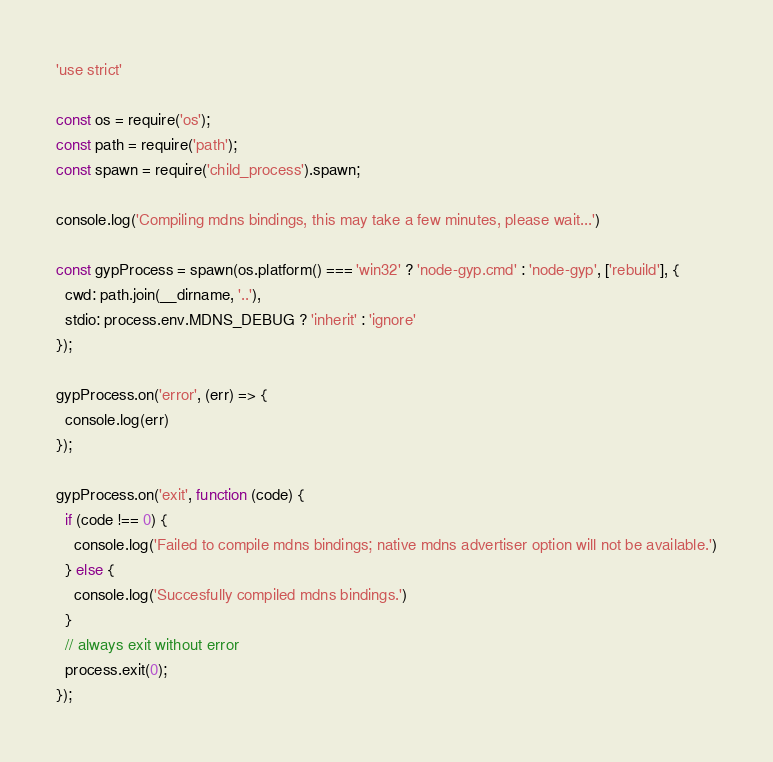<code> <loc_0><loc_0><loc_500><loc_500><_JavaScript_>'use strict'

const os = require('os');
const path = require('path');
const spawn = require('child_process').spawn;

console.log('Compiling mdns bindings, this may take a few minutes, please wait...')

const gypProcess = spawn(os.platform() === 'win32' ? 'node-gyp.cmd' : 'node-gyp', ['rebuild'], {
  cwd: path.join(__dirname, '..'),
  stdio: process.env.MDNS_DEBUG ? 'inherit' : 'ignore' 
});

gypProcess.on('error', (err) => {
  console.log(err)
});

gypProcess.on('exit', function (code) {
  if (code !== 0) {
    console.log('Failed to compile mdns bindings; native mdns advertiser option will not be available.')
  } else {
    console.log('Succesfully compiled mdns bindings.')
  }
  // always exit without error
  process.exit(0);
});
</code> 